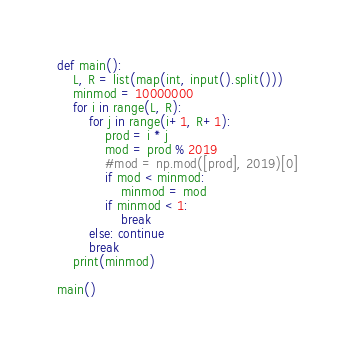Convert code to text. <code><loc_0><loc_0><loc_500><loc_500><_Python_>def main():
    L, R = list(map(int, input().split()))
    minmod = 10000000
    for i in range(L, R):
        for j in range(i+1, R+1):
            prod = i * j
            mod = prod % 2019
            #mod = np.mod([prod], 2019)[0]
            if mod < minmod:
                minmod = mod
            if minmod < 1:
                break
        else: continue
        break
    print(minmod)

main()</code> 